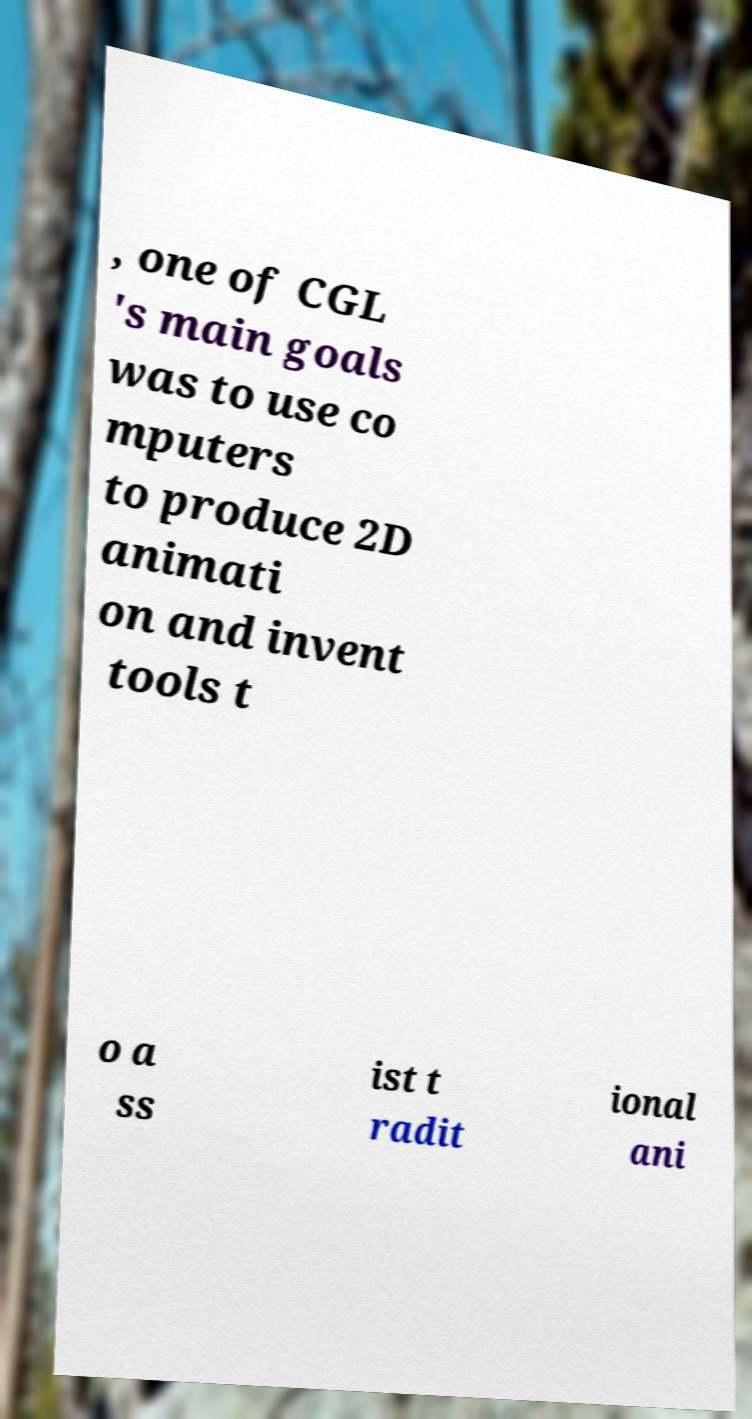I need the written content from this picture converted into text. Can you do that? , one of CGL 's main goals was to use co mputers to produce 2D animati on and invent tools t o a ss ist t radit ional ani 